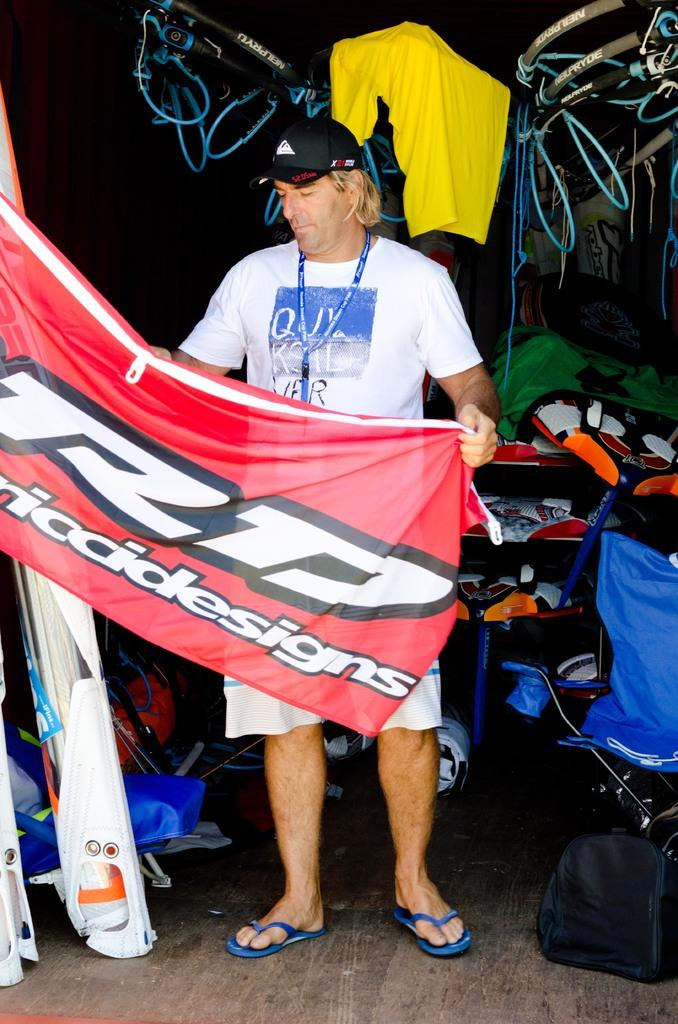<image>
Describe the image concisely. Man  holding a flag and wearing a shirt that has the letter Q on it. 